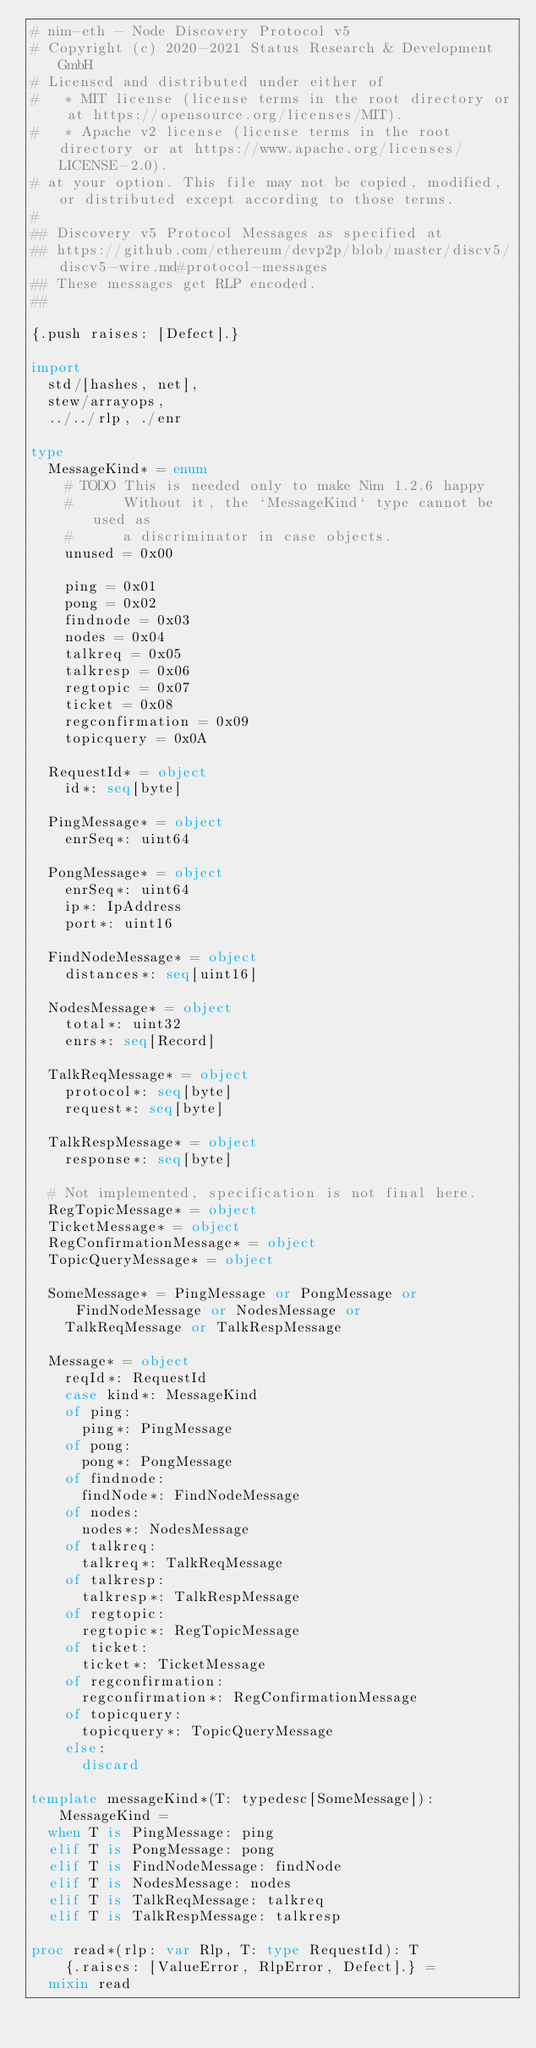Convert code to text. <code><loc_0><loc_0><loc_500><loc_500><_Nim_># nim-eth - Node Discovery Protocol v5
# Copyright (c) 2020-2021 Status Research & Development GmbH
# Licensed and distributed under either of
#   * MIT license (license terms in the root directory or at https://opensource.org/licenses/MIT).
#   * Apache v2 license (license terms in the root directory or at https://www.apache.org/licenses/LICENSE-2.0).
# at your option. This file may not be copied, modified, or distributed except according to those terms.
#
## Discovery v5 Protocol Messages as specified at
## https://github.com/ethereum/devp2p/blob/master/discv5/discv5-wire.md#protocol-messages
## These messages get RLP encoded.
##

{.push raises: [Defect].}

import
  std/[hashes, net],
  stew/arrayops,
  ../../rlp, ./enr

type
  MessageKind* = enum
    # TODO This is needed only to make Nim 1.2.6 happy
    #      Without it, the `MessageKind` type cannot be used as
    #      a discriminator in case objects.
    unused = 0x00

    ping = 0x01
    pong = 0x02
    findnode = 0x03
    nodes = 0x04
    talkreq = 0x05
    talkresp = 0x06
    regtopic = 0x07
    ticket = 0x08
    regconfirmation = 0x09
    topicquery = 0x0A

  RequestId* = object
    id*: seq[byte]

  PingMessage* = object
    enrSeq*: uint64

  PongMessage* = object
    enrSeq*: uint64
    ip*: IpAddress
    port*: uint16

  FindNodeMessage* = object
    distances*: seq[uint16]

  NodesMessage* = object
    total*: uint32
    enrs*: seq[Record]

  TalkReqMessage* = object
    protocol*: seq[byte]
    request*: seq[byte]

  TalkRespMessage* = object
    response*: seq[byte]

  # Not implemented, specification is not final here.
  RegTopicMessage* = object
  TicketMessage* = object
  RegConfirmationMessage* = object
  TopicQueryMessage* = object

  SomeMessage* = PingMessage or PongMessage or FindNodeMessage or NodesMessage or
    TalkReqMessage or TalkRespMessage

  Message* = object
    reqId*: RequestId
    case kind*: MessageKind
    of ping:
      ping*: PingMessage
    of pong:
      pong*: PongMessage
    of findnode:
      findNode*: FindNodeMessage
    of nodes:
      nodes*: NodesMessage
    of talkreq:
      talkreq*: TalkReqMessage
    of talkresp:
      talkresp*: TalkRespMessage
    of regtopic:
      regtopic*: RegTopicMessage
    of ticket:
      ticket*: TicketMessage
    of regconfirmation:
      regconfirmation*: RegConfirmationMessage
    of topicquery:
      topicquery*: TopicQueryMessage
    else:
      discard

template messageKind*(T: typedesc[SomeMessage]): MessageKind =
  when T is PingMessage: ping
  elif T is PongMessage: pong
  elif T is FindNodeMessage: findNode
  elif T is NodesMessage: nodes
  elif T is TalkReqMessage: talkreq
  elif T is TalkRespMessage: talkresp

proc read*(rlp: var Rlp, T: type RequestId): T
    {.raises: [ValueError, RlpError, Defect].} =
  mixin read</code> 